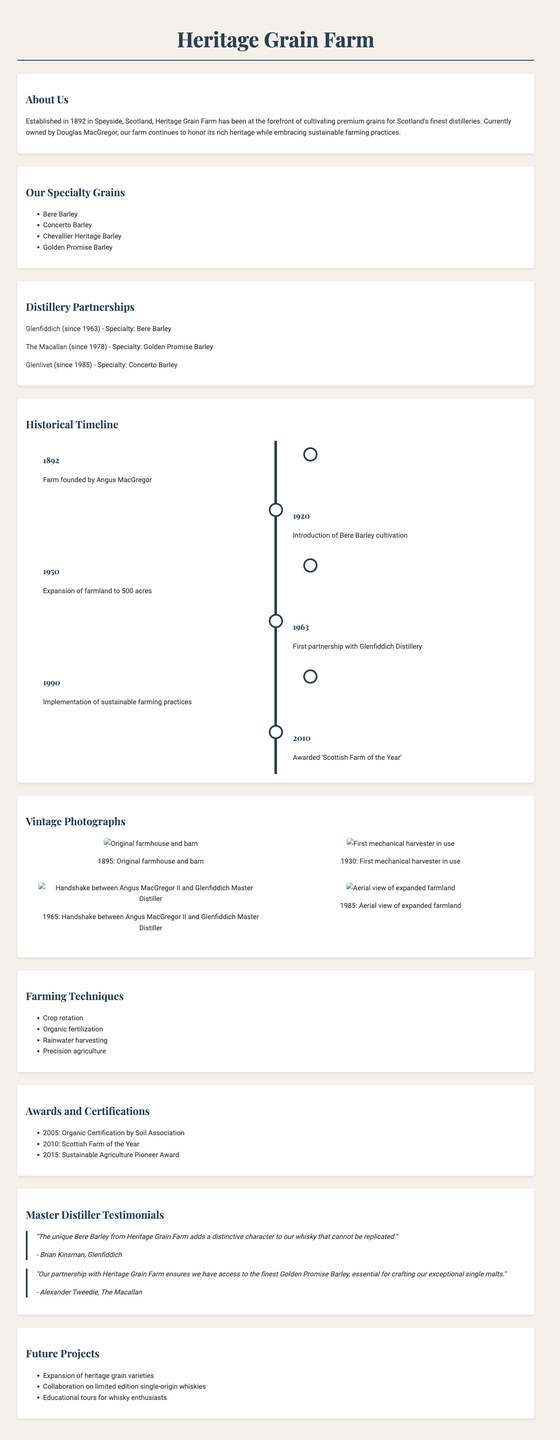What year was Heritage Grain Farm established? The establishment year of Heritage Grain Farm is mentioned in the document as 1892.
Answer: 1892 Who currently owns Heritage Grain Farm? The document specifies that the current owner of the farm is Douglas MacGregor.
Answer: Douglas MacGregor Which grain is specially cultivated for Glenlivet Distillery? The document lists Concerto Barley as the specialty grain for Glenlivet Distillery.
Answer: Concerto Barley What significant farming practice was implemented in 1990? The document states that sustainable farming practices were implemented in the year 1990.
Answer: Sustainable farming practices What award did the farm receive in 2010? The document indicates that the farm was awarded 'Scottish Farm of the Year' in 2010.
Answer: Scottish Farm of the Year Which photograph shows the original farmhouse? The vintage photographs section describes an image from 1895 showing the original farmhouse and barn.
Answer: Original farmhouse and barn How many acres did the farm expand to in 1950? The document mentions that the farmland expanded to 500 acres in 1950.
Answer: 500 acres What is one of the future projects mentioned in the document? The future projects include "Expansion of heritage grain varieties," among others listed in the document.
Answer: Expansion of heritage grain varieties Which distillery partnership started in 1978? The document indicates that the partnership with The Macallan started in 1978.
Answer: The Macallan 